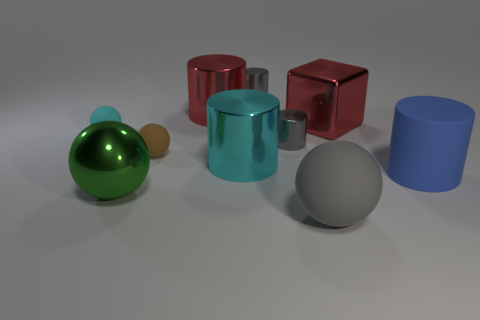Is the color of the big matte ball the same as the block?
Offer a very short reply. No. What number of spheres are either blue things or large things?
Offer a very short reply. 2. Are there fewer cyan objects to the left of the tiny brown rubber thing than yellow balls?
Offer a very short reply. No. There is a big gray thing that is made of the same material as the big blue cylinder; what is its shape?
Your response must be concise. Sphere. How many metal objects have the same color as the big metallic block?
Provide a short and direct response. 1. What number of things are either large metal cylinders or small blue metal spheres?
Offer a terse response. 2. There is a gray cylinder in front of the big metallic object behind the big metal block; what is it made of?
Provide a succinct answer. Metal. Are there any gray cylinders that have the same material as the big blue thing?
Provide a succinct answer. No. There is a matte object in front of the large shiny thing in front of the cyan thing in front of the brown object; what is its shape?
Make the answer very short. Sphere. What is the material of the big cyan cylinder?
Give a very brief answer. Metal. 